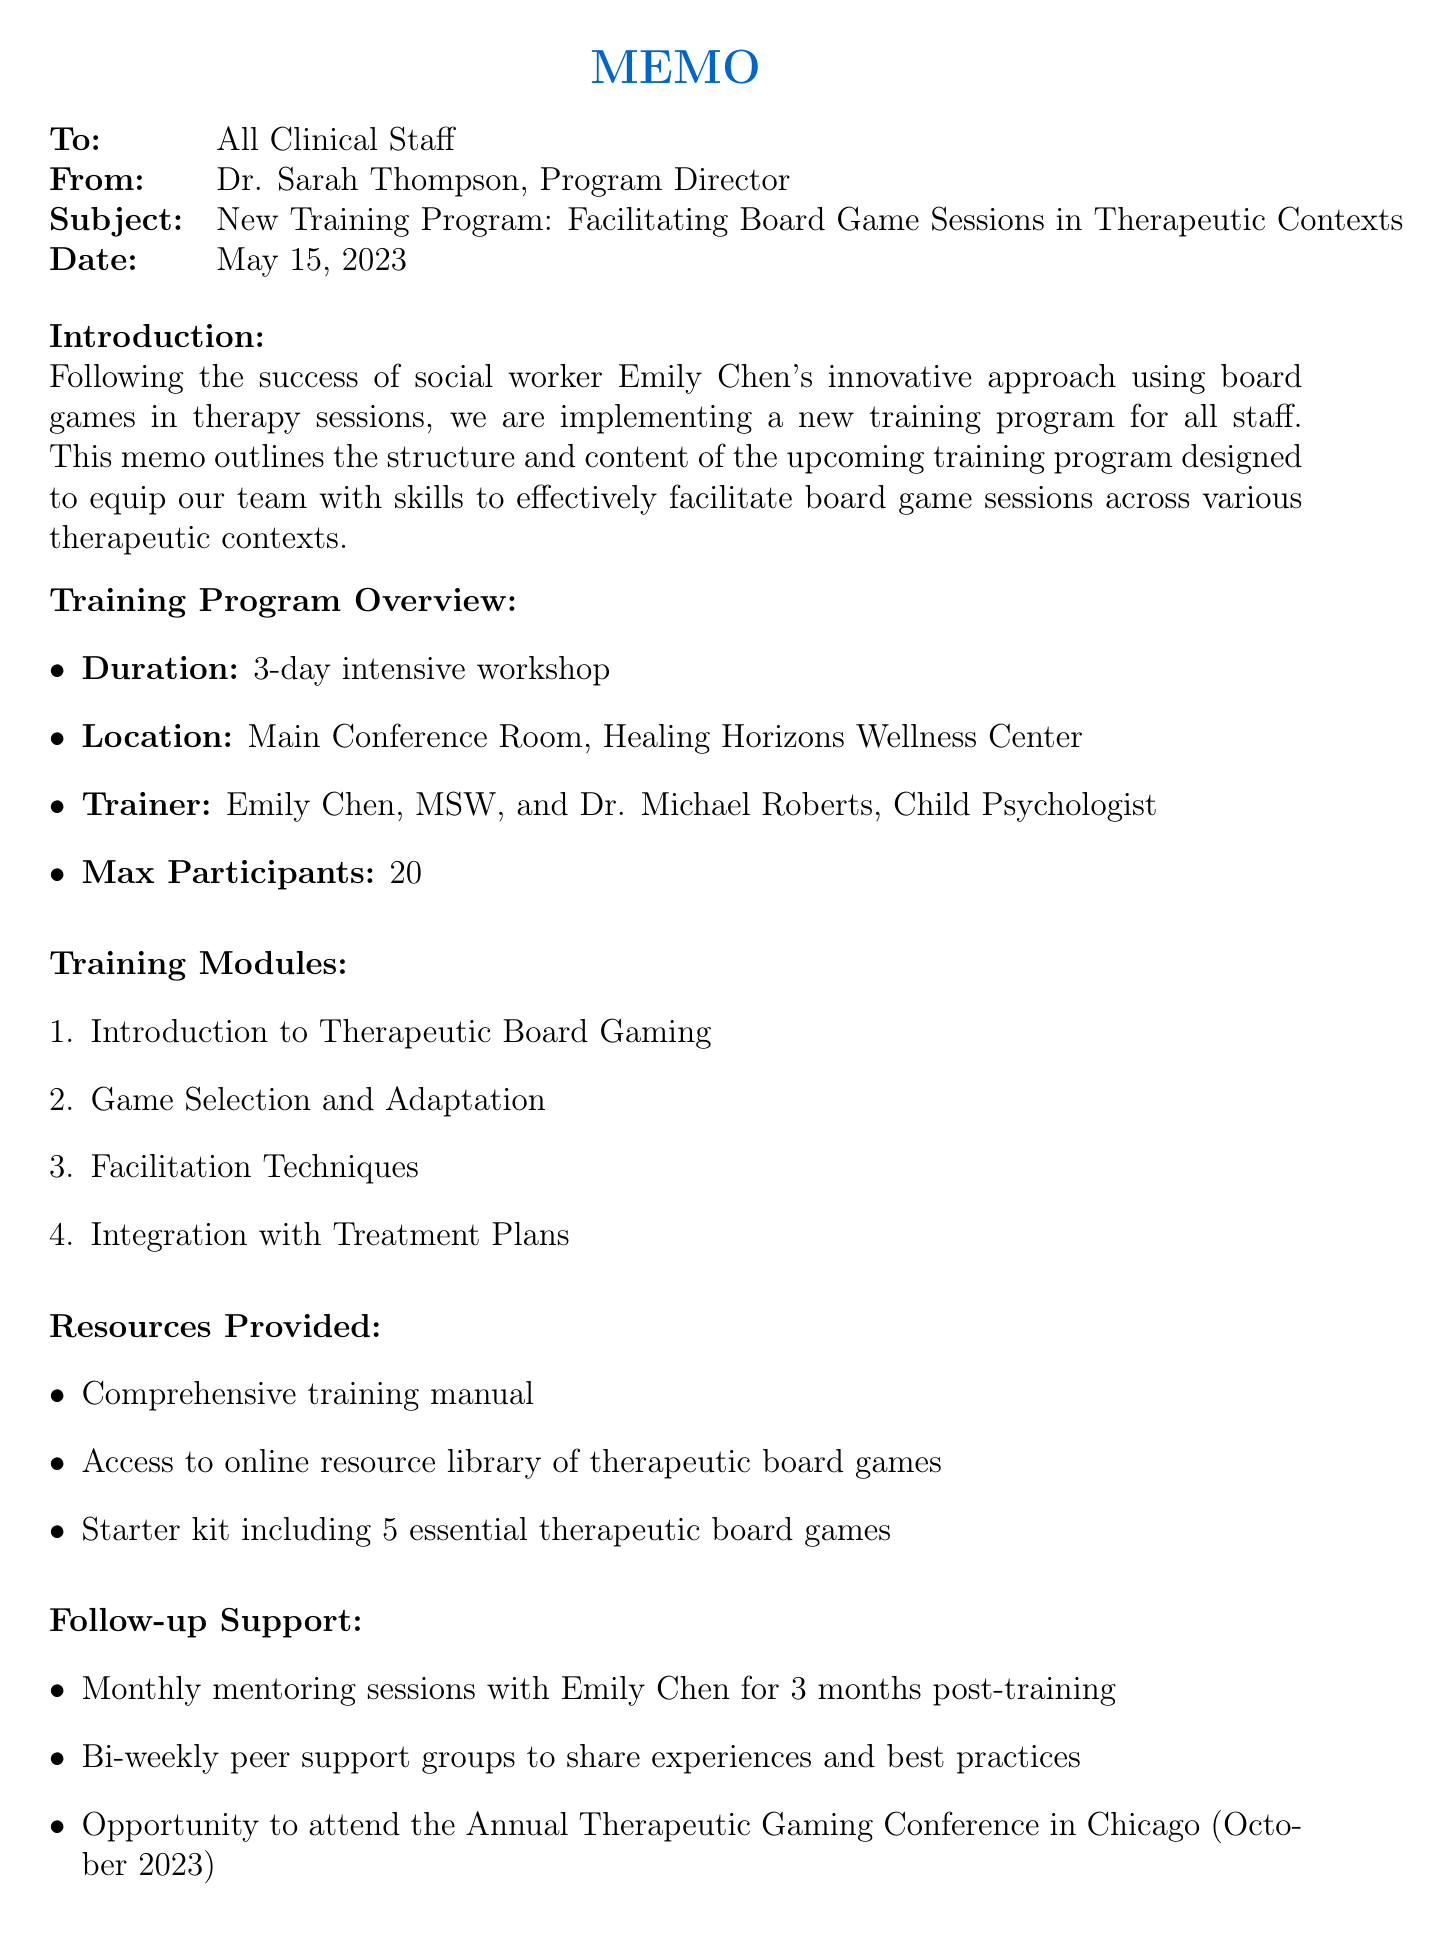What is the date of the memo? The date of the memo is specified in the header, which reads May 15, 2023.
Answer: May 15, 2023 Who are the trainers for the program? The trainers are mentioned in the training program overview section, identified as Emily Chen, MSW, and Dr. Michael Roberts, Child Psychologist.
Answer: Emily Chen, MSW, and Dr. Michael Roberts, Child Psychologist What is the maximum number of participants? The maximum number of participants for the training program is stated as 20 in the training program overview section.
Answer: 20 What is the deadline for registration? The registration deadline is clearly stated under the registration section of the memo as May 31, 2023.
Answer: May 31, 2023 What do the training modules aim to cover? The training modules encompass various topics included in the document, signifying a focus on board gaming methodologies in therapy.
Answer: Introduction to Therapeutic Board Gaming, Game Selection and Adaptation, Facilitation Techniques, Integration with Treatment Plans What type of support will staff receive after the training? Follow-up support includes monthly mentoring sessions, bi-weekly peer support groups, and an opportunity to attend a conference, elaborated in the follow-up support section.
Answer: Monthly mentoring, bi-weekly peer support, conference opportunity How long is the training workshop? The duration of the training program is outlined as a 3-day intensive workshop in the overview section.
Answer: 3-day intensive workshop What is a prerequisite for attending the training? A prerequisite is indicated in the registration section, stipulating the completion of an online pre-training module on basic game theory.
Answer: Completion of online pre-training module on basic game theory 